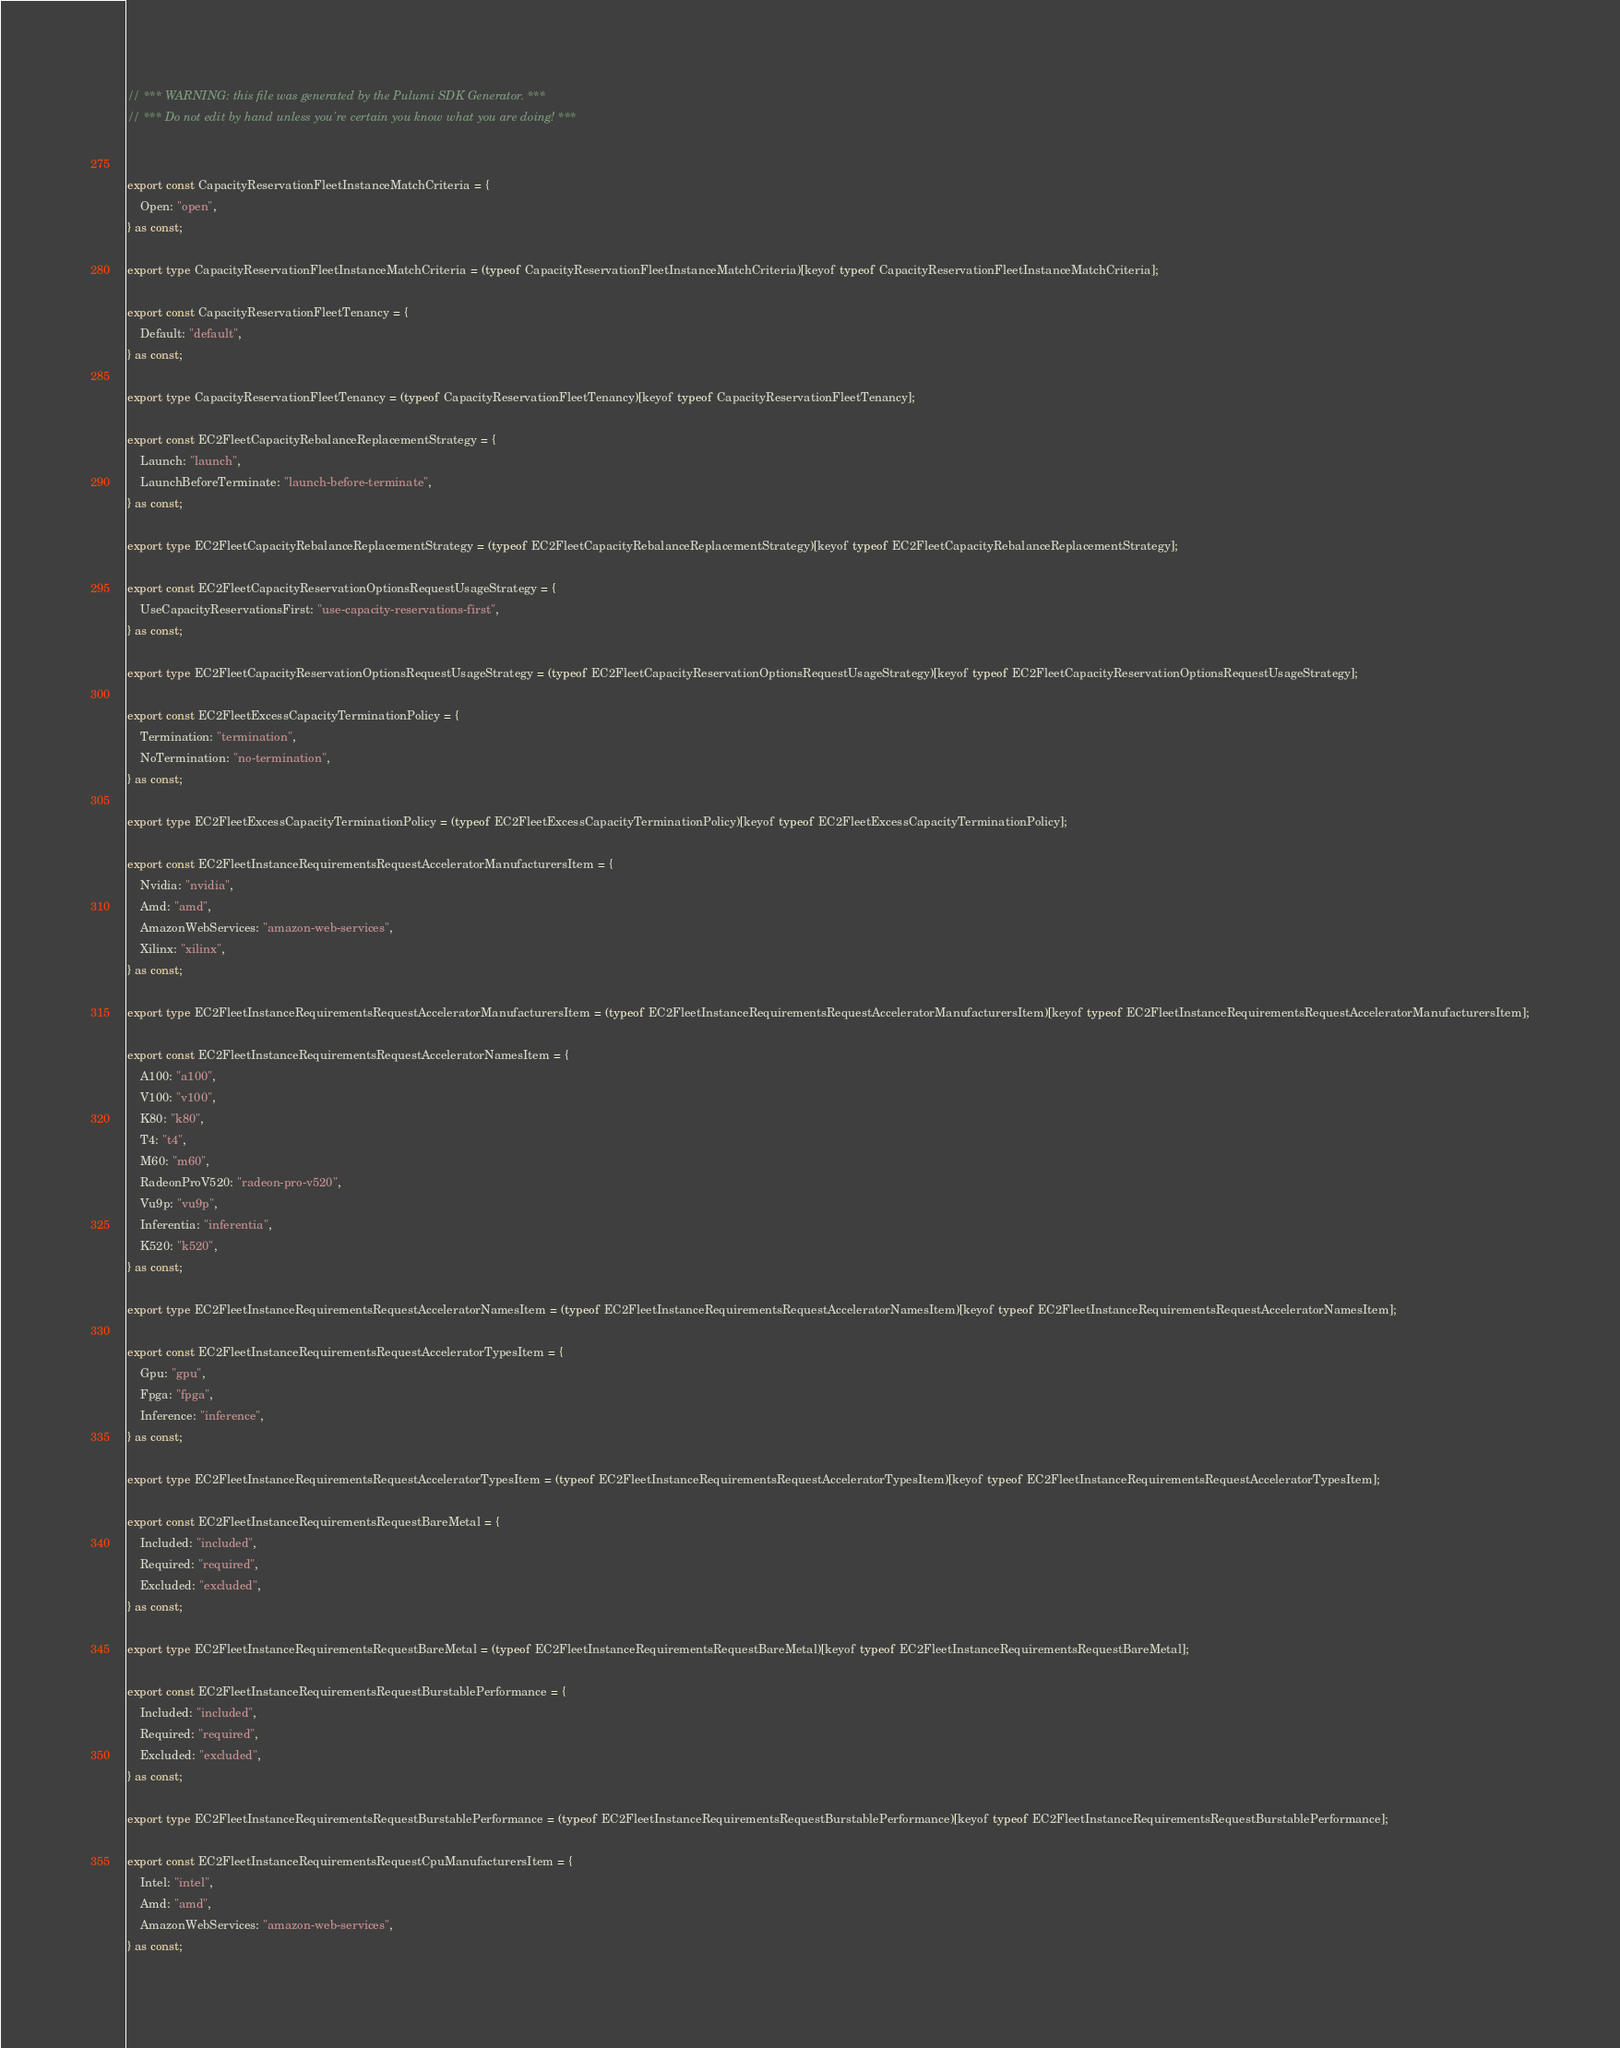<code> <loc_0><loc_0><loc_500><loc_500><_TypeScript_>// *** WARNING: this file was generated by the Pulumi SDK Generator. ***
// *** Do not edit by hand unless you're certain you know what you are doing! ***


export const CapacityReservationFleetInstanceMatchCriteria = {
    Open: "open",
} as const;

export type CapacityReservationFleetInstanceMatchCriteria = (typeof CapacityReservationFleetInstanceMatchCriteria)[keyof typeof CapacityReservationFleetInstanceMatchCriteria];

export const CapacityReservationFleetTenancy = {
    Default: "default",
} as const;

export type CapacityReservationFleetTenancy = (typeof CapacityReservationFleetTenancy)[keyof typeof CapacityReservationFleetTenancy];

export const EC2FleetCapacityRebalanceReplacementStrategy = {
    Launch: "launch",
    LaunchBeforeTerminate: "launch-before-terminate",
} as const;

export type EC2FleetCapacityRebalanceReplacementStrategy = (typeof EC2FleetCapacityRebalanceReplacementStrategy)[keyof typeof EC2FleetCapacityRebalanceReplacementStrategy];

export const EC2FleetCapacityReservationOptionsRequestUsageStrategy = {
    UseCapacityReservationsFirst: "use-capacity-reservations-first",
} as const;

export type EC2FleetCapacityReservationOptionsRequestUsageStrategy = (typeof EC2FleetCapacityReservationOptionsRequestUsageStrategy)[keyof typeof EC2FleetCapacityReservationOptionsRequestUsageStrategy];

export const EC2FleetExcessCapacityTerminationPolicy = {
    Termination: "termination",
    NoTermination: "no-termination",
} as const;

export type EC2FleetExcessCapacityTerminationPolicy = (typeof EC2FleetExcessCapacityTerminationPolicy)[keyof typeof EC2FleetExcessCapacityTerminationPolicy];

export const EC2FleetInstanceRequirementsRequestAcceleratorManufacturersItem = {
    Nvidia: "nvidia",
    Amd: "amd",
    AmazonWebServices: "amazon-web-services",
    Xilinx: "xilinx",
} as const;

export type EC2FleetInstanceRequirementsRequestAcceleratorManufacturersItem = (typeof EC2FleetInstanceRequirementsRequestAcceleratorManufacturersItem)[keyof typeof EC2FleetInstanceRequirementsRequestAcceleratorManufacturersItem];

export const EC2FleetInstanceRequirementsRequestAcceleratorNamesItem = {
    A100: "a100",
    V100: "v100",
    K80: "k80",
    T4: "t4",
    M60: "m60",
    RadeonProV520: "radeon-pro-v520",
    Vu9p: "vu9p",
    Inferentia: "inferentia",
    K520: "k520",
} as const;

export type EC2FleetInstanceRequirementsRequestAcceleratorNamesItem = (typeof EC2FleetInstanceRequirementsRequestAcceleratorNamesItem)[keyof typeof EC2FleetInstanceRequirementsRequestAcceleratorNamesItem];

export const EC2FleetInstanceRequirementsRequestAcceleratorTypesItem = {
    Gpu: "gpu",
    Fpga: "fpga",
    Inference: "inference",
} as const;

export type EC2FleetInstanceRequirementsRequestAcceleratorTypesItem = (typeof EC2FleetInstanceRequirementsRequestAcceleratorTypesItem)[keyof typeof EC2FleetInstanceRequirementsRequestAcceleratorTypesItem];

export const EC2FleetInstanceRequirementsRequestBareMetal = {
    Included: "included",
    Required: "required",
    Excluded: "excluded",
} as const;

export type EC2FleetInstanceRequirementsRequestBareMetal = (typeof EC2FleetInstanceRequirementsRequestBareMetal)[keyof typeof EC2FleetInstanceRequirementsRequestBareMetal];

export const EC2FleetInstanceRequirementsRequestBurstablePerformance = {
    Included: "included",
    Required: "required",
    Excluded: "excluded",
} as const;

export type EC2FleetInstanceRequirementsRequestBurstablePerformance = (typeof EC2FleetInstanceRequirementsRequestBurstablePerformance)[keyof typeof EC2FleetInstanceRequirementsRequestBurstablePerformance];

export const EC2FleetInstanceRequirementsRequestCpuManufacturersItem = {
    Intel: "intel",
    Amd: "amd",
    AmazonWebServices: "amazon-web-services",
} as const;
</code> 